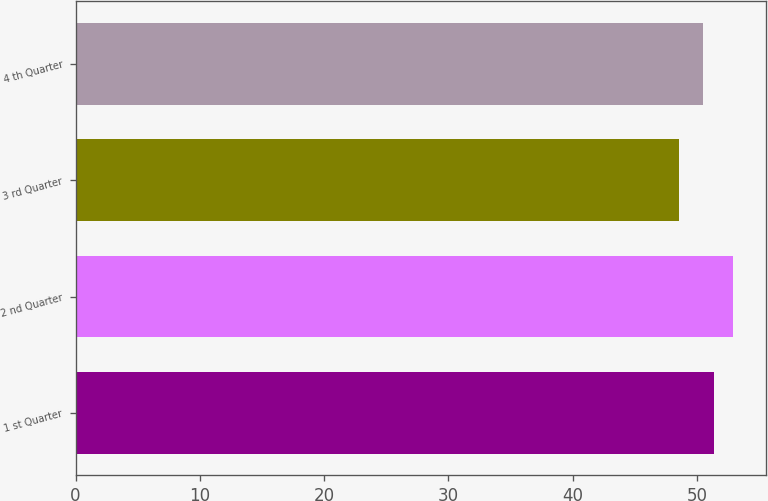Convert chart. <chart><loc_0><loc_0><loc_500><loc_500><bar_chart><fcel>1 st Quarter<fcel>2 nd Quarter<fcel>3 rd Quarter<fcel>4 th Quarter<nl><fcel>51.4<fcel>52.9<fcel>48.57<fcel>50.51<nl></chart> 